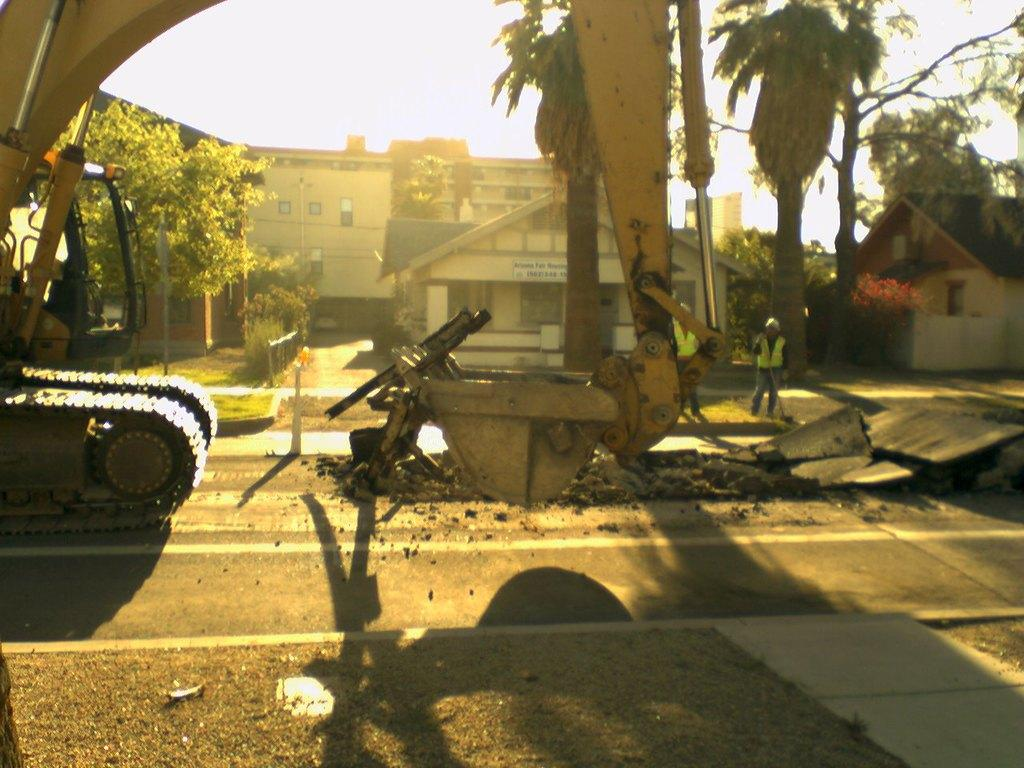What type of construction vehicle can be seen on the road in the image? There is an excavator on the road in the image. What type of natural vegetation is present in the image? There are trees and grass in the image. What type of structures are visible in the image? There are buildings with windows in the image. What type of signage is present in the image? There is a name board in the image. What type of barrier is present in the image? There is a fence in the image. How many people are present in the image? There are two people standing in the image. What is visible in the background of the image? The sky is visible in the background of the image. What type of nut is being used to secure the locket in the image? There is no nut or locket present in the image. What type of spot is visible on the excavator in the image? There are no spots visible on the excavator in the image. 